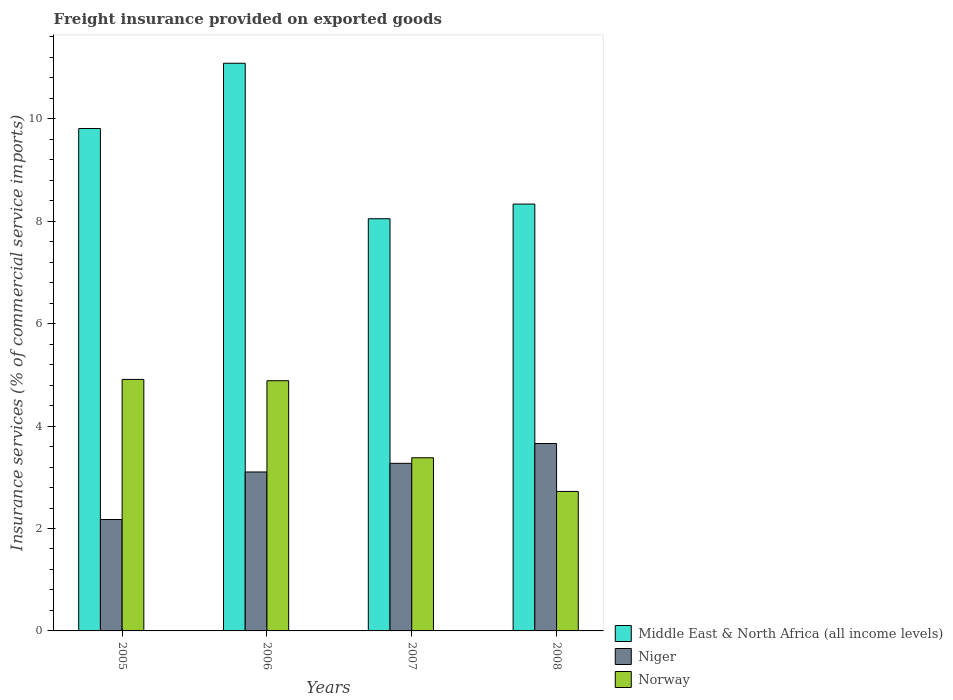How many groups of bars are there?
Make the answer very short. 4. Are the number of bars on each tick of the X-axis equal?
Provide a short and direct response. Yes. What is the freight insurance provided on exported goods in Niger in 2007?
Make the answer very short. 3.27. Across all years, what is the maximum freight insurance provided on exported goods in Middle East & North Africa (all income levels)?
Make the answer very short. 11.09. Across all years, what is the minimum freight insurance provided on exported goods in Norway?
Give a very brief answer. 2.72. In which year was the freight insurance provided on exported goods in Niger minimum?
Offer a very short reply. 2005. What is the total freight insurance provided on exported goods in Middle East & North Africa (all income levels) in the graph?
Offer a very short reply. 37.29. What is the difference between the freight insurance provided on exported goods in Niger in 2005 and that in 2006?
Your response must be concise. -0.93. What is the difference between the freight insurance provided on exported goods in Norway in 2007 and the freight insurance provided on exported goods in Middle East & North Africa (all income levels) in 2008?
Give a very brief answer. -4.95. What is the average freight insurance provided on exported goods in Niger per year?
Provide a short and direct response. 3.05. In the year 2007, what is the difference between the freight insurance provided on exported goods in Niger and freight insurance provided on exported goods in Middle East & North Africa (all income levels)?
Your answer should be very brief. -4.78. In how many years, is the freight insurance provided on exported goods in Middle East & North Africa (all income levels) greater than 8.8 %?
Provide a short and direct response. 2. What is the ratio of the freight insurance provided on exported goods in Norway in 2006 to that in 2008?
Your answer should be very brief. 1.79. What is the difference between the highest and the second highest freight insurance provided on exported goods in Niger?
Offer a terse response. 0.39. What is the difference between the highest and the lowest freight insurance provided on exported goods in Niger?
Offer a very short reply. 1.48. What does the 1st bar from the left in 2006 represents?
Provide a short and direct response. Middle East & North Africa (all income levels). What does the 3rd bar from the right in 2006 represents?
Your response must be concise. Middle East & North Africa (all income levels). Is it the case that in every year, the sum of the freight insurance provided on exported goods in Norway and freight insurance provided on exported goods in Niger is greater than the freight insurance provided on exported goods in Middle East & North Africa (all income levels)?
Your answer should be very brief. No. How many bars are there?
Ensure brevity in your answer.  12. Are all the bars in the graph horizontal?
Your answer should be compact. No. How many years are there in the graph?
Offer a very short reply. 4. Does the graph contain any zero values?
Your answer should be compact. No. Where does the legend appear in the graph?
Your answer should be very brief. Bottom right. How many legend labels are there?
Offer a very short reply. 3. How are the legend labels stacked?
Offer a very short reply. Vertical. What is the title of the graph?
Keep it short and to the point. Freight insurance provided on exported goods. Does "Cameroon" appear as one of the legend labels in the graph?
Your answer should be very brief. No. What is the label or title of the X-axis?
Your response must be concise. Years. What is the label or title of the Y-axis?
Provide a short and direct response. Insurance services (% of commercial service imports). What is the Insurance services (% of commercial service imports) in Middle East & North Africa (all income levels) in 2005?
Keep it short and to the point. 9.81. What is the Insurance services (% of commercial service imports) of Niger in 2005?
Offer a very short reply. 2.18. What is the Insurance services (% of commercial service imports) of Norway in 2005?
Keep it short and to the point. 4.91. What is the Insurance services (% of commercial service imports) in Middle East & North Africa (all income levels) in 2006?
Provide a succinct answer. 11.09. What is the Insurance services (% of commercial service imports) in Niger in 2006?
Ensure brevity in your answer.  3.1. What is the Insurance services (% of commercial service imports) of Norway in 2006?
Make the answer very short. 4.89. What is the Insurance services (% of commercial service imports) in Middle East & North Africa (all income levels) in 2007?
Provide a short and direct response. 8.05. What is the Insurance services (% of commercial service imports) in Niger in 2007?
Provide a short and direct response. 3.27. What is the Insurance services (% of commercial service imports) in Norway in 2007?
Ensure brevity in your answer.  3.38. What is the Insurance services (% of commercial service imports) in Middle East & North Africa (all income levels) in 2008?
Provide a succinct answer. 8.34. What is the Insurance services (% of commercial service imports) in Niger in 2008?
Keep it short and to the point. 3.66. What is the Insurance services (% of commercial service imports) in Norway in 2008?
Your answer should be very brief. 2.72. Across all years, what is the maximum Insurance services (% of commercial service imports) in Middle East & North Africa (all income levels)?
Your answer should be very brief. 11.09. Across all years, what is the maximum Insurance services (% of commercial service imports) in Niger?
Your answer should be very brief. 3.66. Across all years, what is the maximum Insurance services (% of commercial service imports) of Norway?
Provide a short and direct response. 4.91. Across all years, what is the minimum Insurance services (% of commercial service imports) of Middle East & North Africa (all income levels)?
Offer a terse response. 8.05. Across all years, what is the minimum Insurance services (% of commercial service imports) in Niger?
Keep it short and to the point. 2.18. Across all years, what is the minimum Insurance services (% of commercial service imports) in Norway?
Your answer should be compact. 2.72. What is the total Insurance services (% of commercial service imports) of Middle East & North Africa (all income levels) in the graph?
Your answer should be compact. 37.29. What is the total Insurance services (% of commercial service imports) in Niger in the graph?
Your answer should be very brief. 12.21. What is the total Insurance services (% of commercial service imports) in Norway in the graph?
Your response must be concise. 15.9. What is the difference between the Insurance services (% of commercial service imports) of Middle East & North Africa (all income levels) in 2005 and that in 2006?
Your answer should be compact. -1.27. What is the difference between the Insurance services (% of commercial service imports) in Niger in 2005 and that in 2006?
Provide a short and direct response. -0.93. What is the difference between the Insurance services (% of commercial service imports) in Norway in 2005 and that in 2006?
Provide a short and direct response. 0.03. What is the difference between the Insurance services (% of commercial service imports) in Middle East & North Africa (all income levels) in 2005 and that in 2007?
Provide a short and direct response. 1.76. What is the difference between the Insurance services (% of commercial service imports) in Niger in 2005 and that in 2007?
Your response must be concise. -1.1. What is the difference between the Insurance services (% of commercial service imports) of Norway in 2005 and that in 2007?
Offer a terse response. 1.53. What is the difference between the Insurance services (% of commercial service imports) of Middle East & North Africa (all income levels) in 2005 and that in 2008?
Ensure brevity in your answer.  1.48. What is the difference between the Insurance services (% of commercial service imports) in Niger in 2005 and that in 2008?
Your answer should be compact. -1.48. What is the difference between the Insurance services (% of commercial service imports) of Norway in 2005 and that in 2008?
Keep it short and to the point. 2.19. What is the difference between the Insurance services (% of commercial service imports) in Middle East & North Africa (all income levels) in 2006 and that in 2007?
Ensure brevity in your answer.  3.04. What is the difference between the Insurance services (% of commercial service imports) in Niger in 2006 and that in 2007?
Provide a succinct answer. -0.17. What is the difference between the Insurance services (% of commercial service imports) in Norway in 2006 and that in 2007?
Your response must be concise. 1.5. What is the difference between the Insurance services (% of commercial service imports) of Middle East & North Africa (all income levels) in 2006 and that in 2008?
Provide a short and direct response. 2.75. What is the difference between the Insurance services (% of commercial service imports) of Niger in 2006 and that in 2008?
Keep it short and to the point. -0.56. What is the difference between the Insurance services (% of commercial service imports) of Norway in 2006 and that in 2008?
Keep it short and to the point. 2.16. What is the difference between the Insurance services (% of commercial service imports) in Middle East & North Africa (all income levels) in 2007 and that in 2008?
Keep it short and to the point. -0.29. What is the difference between the Insurance services (% of commercial service imports) in Niger in 2007 and that in 2008?
Keep it short and to the point. -0.39. What is the difference between the Insurance services (% of commercial service imports) of Norway in 2007 and that in 2008?
Ensure brevity in your answer.  0.66. What is the difference between the Insurance services (% of commercial service imports) of Middle East & North Africa (all income levels) in 2005 and the Insurance services (% of commercial service imports) of Niger in 2006?
Provide a succinct answer. 6.71. What is the difference between the Insurance services (% of commercial service imports) in Middle East & North Africa (all income levels) in 2005 and the Insurance services (% of commercial service imports) in Norway in 2006?
Give a very brief answer. 4.93. What is the difference between the Insurance services (% of commercial service imports) of Niger in 2005 and the Insurance services (% of commercial service imports) of Norway in 2006?
Provide a succinct answer. -2.71. What is the difference between the Insurance services (% of commercial service imports) in Middle East & North Africa (all income levels) in 2005 and the Insurance services (% of commercial service imports) in Niger in 2007?
Provide a short and direct response. 6.54. What is the difference between the Insurance services (% of commercial service imports) in Middle East & North Africa (all income levels) in 2005 and the Insurance services (% of commercial service imports) in Norway in 2007?
Your response must be concise. 6.43. What is the difference between the Insurance services (% of commercial service imports) of Niger in 2005 and the Insurance services (% of commercial service imports) of Norway in 2007?
Offer a terse response. -1.21. What is the difference between the Insurance services (% of commercial service imports) in Middle East & North Africa (all income levels) in 2005 and the Insurance services (% of commercial service imports) in Niger in 2008?
Your response must be concise. 6.15. What is the difference between the Insurance services (% of commercial service imports) of Middle East & North Africa (all income levels) in 2005 and the Insurance services (% of commercial service imports) of Norway in 2008?
Give a very brief answer. 7.09. What is the difference between the Insurance services (% of commercial service imports) of Niger in 2005 and the Insurance services (% of commercial service imports) of Norway in 2008?
Provide a succinct answer. -0.55. What is the difference between the Insurance services (% of commercial service imports) of Middle East & North Africa (all income levels) in 2006 and the Insurance services (% of commercial service imports) of Niger in 2007?
Offer a very short reply. 7.81. What is the difference between the Insurance services (% of commercial service imports) of Middle East & North Africa (all income levels) in 2006 and the Insurance services (% of commercial service imports) of Norway in 2007?
Ensure brevity in your answer.  7.7. What is the difference between the Insurance services (% of commercial service imports) in Niger in 2006 and the Insurance services (% of commercial service imports) in Norway in 2007?
Keep it short and to the point. -0.28. What is the difference between the Insurance services (% of commercial service imports) in Middle East & North Africa (all income levels) in 2006 and the Insurance services (% of commercial service imports) in Niger in 2008?
Your answer should be compact. 7.43. What is the difference between the Insurance services (% of commercial service imports) in Middle East & North Africa (all income levels) in 2006 and the Insurance services (% of commercial service imports) in Norway in 2008?
Provide a succinct answer. 8.36. What is the difference between the Insurance services (% of commercial service imports) in Niger in 2006 and the Insurance services (% of commercial service imports) in Norway in 2008?
Ensure brevity in your answer.  0.38. What is the difference between the Insurance services (% of commercial service imports) of Middle East & North Africa (all income levels) in 2007 and the Insurance services (% of commercial service imports) of Niger in 2008?
Keep it short and to the point. 4.39. What is the difference between the Insurance services (% of commercial service imports) of Middle East & North Africa (all income levels) in 2007 and the Insurance services (% of commercial service imports) of Norway in 2008?
Offer a terse response. 5.33. What is the difference between the Insurance services (% of commercial service imports) in Niger in 2007 and the Insurance services (% of commercial service imports) in Norway in 2008?
Your answer should be compact. 0.55. What is the average Insurance services (% of commercial service imports) in Middle East & North Africa (all income levels) per year?
Offer a terse response. 9.32. What is the average Insurance services (% of commercial service imports) in Niger per year?
Ensure brevity in your answer.  3.05. What is the average Insurance services (% of commercial service imports) in Norway per year?
Your response must be concise. 3.98. In the year 2005, what is the difference between the Insurance services (% of commercial service imports) in Middle East & North Africa (all income levels) and Insurance services (% of commercial service imports) in Niger?
Provide a succinct answer. 7.64. In the year 2005, what is the difference between the Insurance services (% of commercial service imports) of Middle East & North Africa (all income levels) and Insurance services (% of commercial service imports) of Norway?
Provide a short and direct response. 4.9. In the year 2005, what is the difference between the Insurance services (% of commercial service imports) of Niger and Insurance services (% of commercial service imports) of Norway?
Offer a very short reply. -2.74. In the year 2006, what is the difference between the Insurance services (% of commercial service imports) in Middle East & North Africa (all income levels) and Insurance services (% of commercial service imports) in Niger?
Offer a terse response. 7.98. In the year 2006, what is the difference between the Insurance services (% of commercial service imports) of Middle East & North Africa (all income levels) and Insurance services (% of commercial service imports) of Norway?
Offer a very short reply. 6.2. In the year 2006, what is the difference between the Insurance services (% of commercial service imports) in Niger and Insurance services (% of commercial service imports) in Norway?
Ensure brevity in your answer.  -1.78. In the year 2007, what is the difference between the Insurance services (% of commercial service imports) in Middle East & North Africa (all income levels) and Insurance services (% of commercial service imports) in Niger?
Keep it short and to the point. 4.78. In the year 2007, what is the difference between the Insurance services (% of commercial service imports) in Middle East & North Africa (all income levels) and Insurance services (% of commercial service imports) in Norway?
Offer a very short reply. 4.67. In the year 2007, what is the difference between the Insurance services (% of commercial service imports) of Niger and Insurance services (% of commercial service imports) of Norway?
Give a very brief answer. -0.11. In the year 2008, what is the difference between the Insurance services (% of commercial service imports) of Middle East & North Africa (all income levels) and Insurance services (% of commercial service imports) of Niger?
Offer a terse response. 4.68. In the year 2008, what is the difference between the Insurance services (% of commercial service imports) of Middle East & North Africa (all income levels) and Insurance services (% of commercial service imports) of Norway?
Provide a succinct answer. 5.61. In the year 2008, what is the difference between the Insurance services (% of commercial service imports) in Niger and Insurance services (% of commercial service imports) in Norway?
Provide a succinct answer. 0.94. What is the ratio of the Insurance services (% of commercial service imports) of Middle East & North Africa (all income levels) in 2005 to that in 2006?
Your response must be concise. 0.89. What is the ratio of the Insurance services (% of commercial service imports) in Niger in 2005 to that in 2006?
Make the answer very short. 0.7. What is the ratio of the Insurance services (% of commercial service imports) in Norway in 2005 to that in 2006?
Offer a terse response. 1.01. What is the ratio of the Insurance services (% of commercial service imports) in Middle East & North Africa (all income levels) in 2005 to that in 2007?
Keep it short and to the point. 1.22. What is the ratio of the Insurance services (% of commercial service imports) in Niger in 2005 to that in 2007?
Offer a terse response. 0.66. What is the ratio of the Insurance services (% of commercial service imports) in Norway in 2005 to that in 2007?
Offer a very short reply. 1.45. What is the ratio of the Insurance services (% of commercial service imports) in Middle East & North Africa (all income levels) in 2005 to that in 2008?
Your answer should be very brief. 1.18. What is the ratio of the Insurance services (% of commercial service imports) in Niger in 2005 to that in 2008?
Offer a very short reply. 0.59. What is the ratio of the Insurance services (% of commercial service imports) in Norway in 2005 to that in 2008?
Make the answer very short. 1.8. What is the ratio of the Insurance services (% of commercial service imports) in Middle East & North Africa (all income levels) in 2006 to that in 2007?
Offer a very short reply. 1.38. What is the ratio of the Insurance services (% of commercial service imports) in Niger in 2006 to that in 2007?
Your response must be concise. 0.95. What is the ratio of the Insurance services (% of commercial service imports) in Norway in 2006 to that in 2007?
Your answer should be compact. 1.45. What is the ratio of the Insurance services (% of commercial service imports) of Middle East & North Africa (all income levels) in 2006 to that in 2008?
Keep it short and to the point. 1.33. What is the ratio of the Insurance services (% of commercial service imports) in Niger in 2006 to that in 2008?
Your response must be concise. 0.85. What is the ratio of the Insurance services (% of commercial service imports) of Norway in 2006 to that in 2008?
Your response must be concise. 1.79. What is the ratio of the Insurance services (% of commercial service imports) of Middle East & North Africa (all income levels) in 2007 to that in 2008?
Provide a succinct answer. 0.97. What is the ratio of the Insurance services (% of commercial service imports) of Niger in 2007 to that in 2008?
Provide a short and direct response. 0.89. What is the ratio of the Insurance services (% of commercial service imports) of Norway in 2007 to that in 2008?
Keep it short and to the point. 1.24. What is the difference between the highest and the second highest Insurance services (% of commercial service imports) of Middle East & North Africa (all income levels)?
Your answer should be compact. 1.27. What is the difference between the highest and the second highest Insurance services (% of commercial service imports) in Niger?
Make the answer very short. 0.39. What is the difference between the highest and the second highest Insurance services (% of commercial service imports) of Norway?
Offer a very short reply. 0.03. What is the difference between the highest and the lowest Insurance services (% of commercial service imports) in Middle East & North Africa (all income levels)?
Ensure brevity in your answer.  3.04. What is the difference between the highest and the lowest Insurance services (% of commercial service imports) of Niger?
Offer a terse response. 1.48. What is the difference between the highest and the lowest Insurance services (% of commercial service imports) of Norway?
Your answer should be compact. 2.19. 